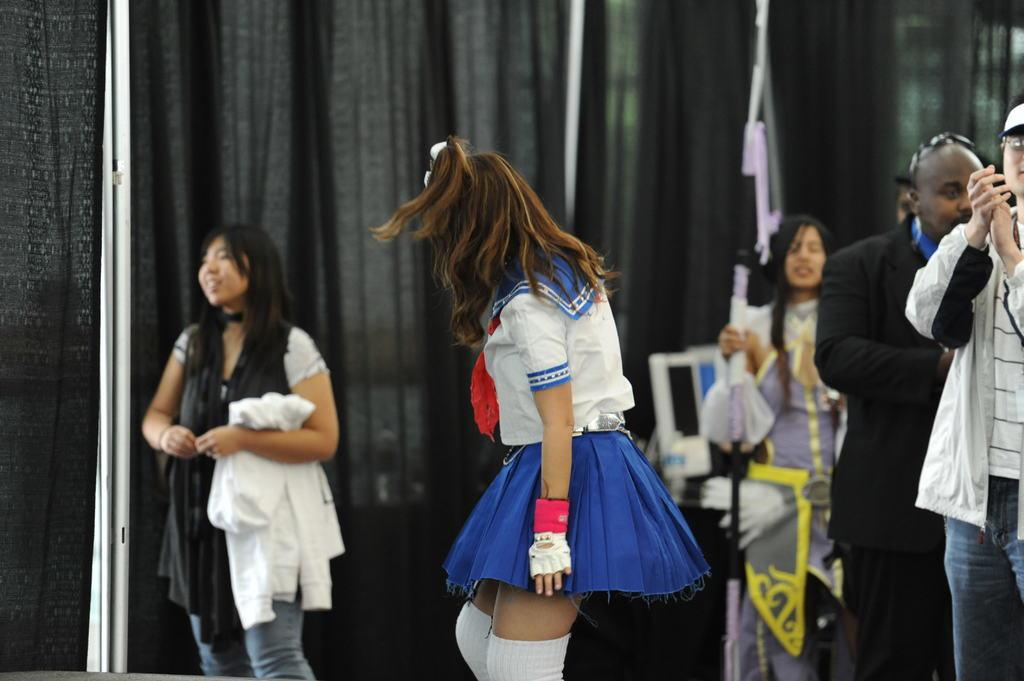What are the people in the image doing? The people in the image are standing on the ground. What can be seen in the background of the image? There are curtains visible in the image. What is behind the people in the image? There are objects behind the people. What action is the man in the image performing? A man is clapping in the image. What type of haircut does the plantation owner have in the image? There is no plantation or plantation owner present in the image. How many dimes can be seen on the ground in the image? There are no dimes visible on the ground in the image. 